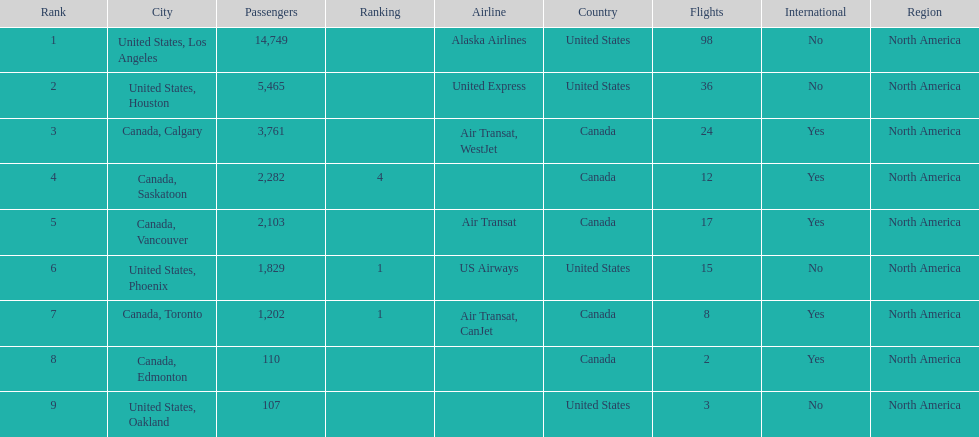Would you mind parsing the complete table? {'header': ['Rank', 'City', 'Passengers', 'Ranking', 'Airline', 'Country', 'Flights', 'International', 'Region'], 'rows': [['1', 'United States, Los Angeles', '14,749', '', 'Alaska Airlines', 'United States', '98', 'No', 'North America'], ['2', 'United States, Houston', '5,465', '', 'United Express', 'United States', '36', 'No', 'North America'], ['3', 'Canada, Calgary', '3,761', '', 'Air Transat, WestJet', 'Canada', '24', 'Yes', 'North America'], ['4', 'Canada, Saskatoon', '2,282', '4', '', 'Canada', '12', 'Yes', 'North America'], ['5', 'Canada, Vancouver', '2,103', '', 'Air Transat', 'Canada', '17', 'Yes', 'North America'], ['6', 'United States, Phoenix', '1,829', '1', 'US Airways', 'United States', '15', 'No', 'North America'], ['7', 'Canada, Toronto', '1,202', '1', 'Air Transat, CanJet', 'Canada', '8', 'Yes', 'North America'], ['8', 'Canada, Edmonton', '110', '', '', 'Canada', '2', 'Yes', 'North America'], ['9', 'United States, Oakland', '107', '', '', 'United States', '3', 'No', 'North America']]} Which canadian city had the most passengers traveling from manzanillo international airport in 2013? Calgary. 